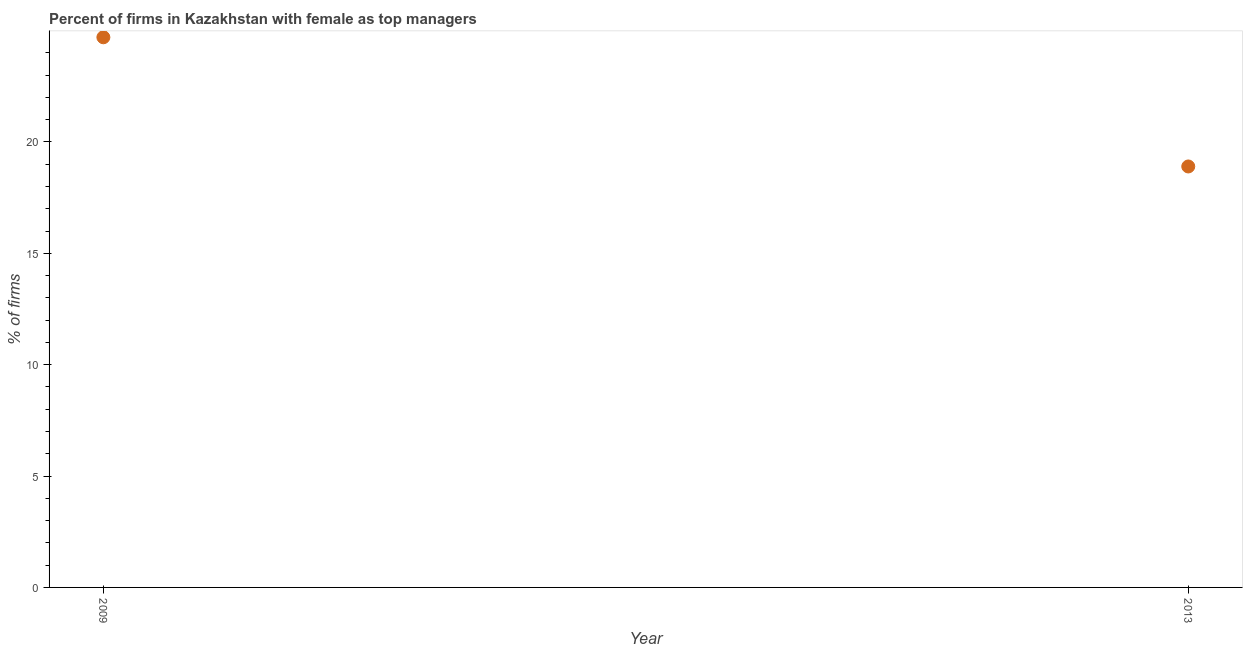Across all years, what is the maximum percentage of firms with female as top manager?
Your response must be concise. 24.7. Across all years, what is the minimum percentage of firms with female as top manager?
Keep it short and to the point. 18.9. What is the sum of the percentage of firms with female as top manager?
Offer a very short reply. 43.6. What is the difference between the percentage of firms with female as top manager in 2009 and 2013?
Your answer should be compact. 5.8. What is the average percentage of firms with female as top manager per year?
Your response must be concise. 21.8. What is the median percentage of firms with female as top manager?
Offer a very short reply. 21.8. Do a majority of the years between 2009 and 2013 (inclusive) have percentage of firms with female as top manager greater than 8 %?
Give a very brief answer. Yes. What is the ratio of the percentage of firms with female as top manager in 2009 to that in 2013?
Make the answer very short. 1.31. In how many years, is the percentage of firms with female as top manager greater than the average percentage of firms with female as top manager taken over all years?
Keep it short and to the point. 1. Does the percentage of firms with female as top manager monotonically increase over the years?
Provide a short and direct response. No. Are the values on the major ticks of Y-axis written in scientific E-notation?
Provide a short and direct response. No. Does the graph contain any zero values?
Ensure brevity in your answer.  No. What is the title of the graph?
Make the answer very short. Percent of firms in Kazakhstan with female as top managers. What is the label or title of the Y-axis?
Your response must be concise. % of firms. What is the % of firms in 2009?
Give a very brief answer. 24.7. What is the % of firms in 2013?
Your answer should be very brief. 18.9. What is the ratio of the % of firms in 2009 to that in 2013?
Make the answer very short. 1.31. 